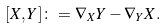<formula> <loc_0><loc_0><loc_500><loc_500>[ X , Y ] \colon = \nabla _ { X } Y - \nabla _ { Y } X .</formula> 